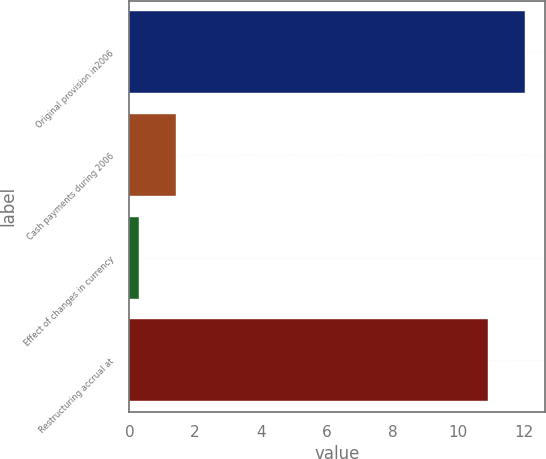Convert chart. <chart><loc_0><loc_0><loc_500><loc_500><bar_chart><fcel>Original provision in2006<fcel>Cash payments during 2006<fcel>Effect of changes in currency<fcel>Restructuring accrual at<nl><fcel>12.03<fcel>1.43<fcel>0.3<fcel>10.9<nl></chart> 